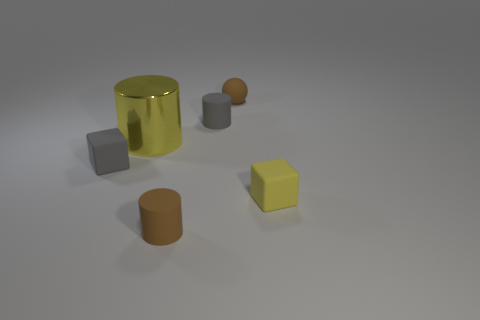The small rubber object in front of the yellow thing in front of the rubber block that is left of the large yellow shiny object is what color?
Your answer should be very brief. Brown. Are the ball that is right of the gray cube and the small gray cylinder made of the same material?
Ensure brevity in your answer.  Yes. Are there any big metal things that have the same color as the big cylinder?
Your answer should be very brief. No. Are there any tiny purple metal cubes?
Keep it short and to the point. No. Do the cube to the right of the brown rubber sphere and the gray rubber cylinder have the same size?
Your response must be concise. Yes. Is the number of tiny matte cylinders less than the number of tiny cyan metal balls?
Ensure brevity in your answer.  No. What is the shape of the tiny matte thing that is to the right of the small brown ball that is to the right of the large yellow shiny thing that is left of the small brown cylinder?
Your answer should be very brief. Cube. Is there a brown ball made of the same material as the large cylinder?
Your answer should be compact. No. There is a matte cylinder that is in front of the small gray rubber cylinder; does it have the same color as the matte block that is to the right of the tiny gray cube?
Offer a very short reply. No. Are there fewer tiny gray cubes on the left side of the small gray rubber cube than large shiny cubes?
Keep it short and to the point. No. 